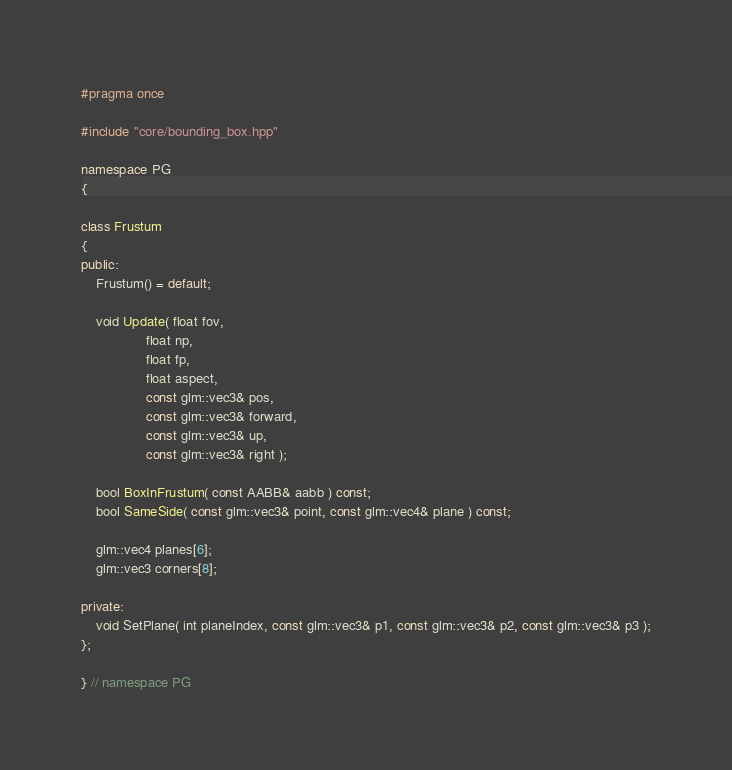Convert code to text. <code><loc_0><loc_0><loc_500><loc_500><_C++_>#pragma once

#include "core/bounding_box.hpp"

namespace PG
{

class Frustum
{
public:
    Frustum() = default;

    void Update( float fov,
                 float np,
                 float fp,
                 float aspect,
                 const glm::vec3& pos,
                 const glm::vec3& forward,
                 const glm::vec3& up,
                 const glm::vec3& right );

    bool BoxInFrustum( const AABB& aabb ) const;
    bool SameSide( const glm::vec3& point, const glm::vec4& plane ) const;

    glm::vec4 planes[6];
    glm::vec3 corners[8];

private:
    void SetPlane( int planeIndex, const glm::vec3& p1, const glm::vec3& p2, const glm::vec3& p3 );
};

} // namespace PG
</code> 